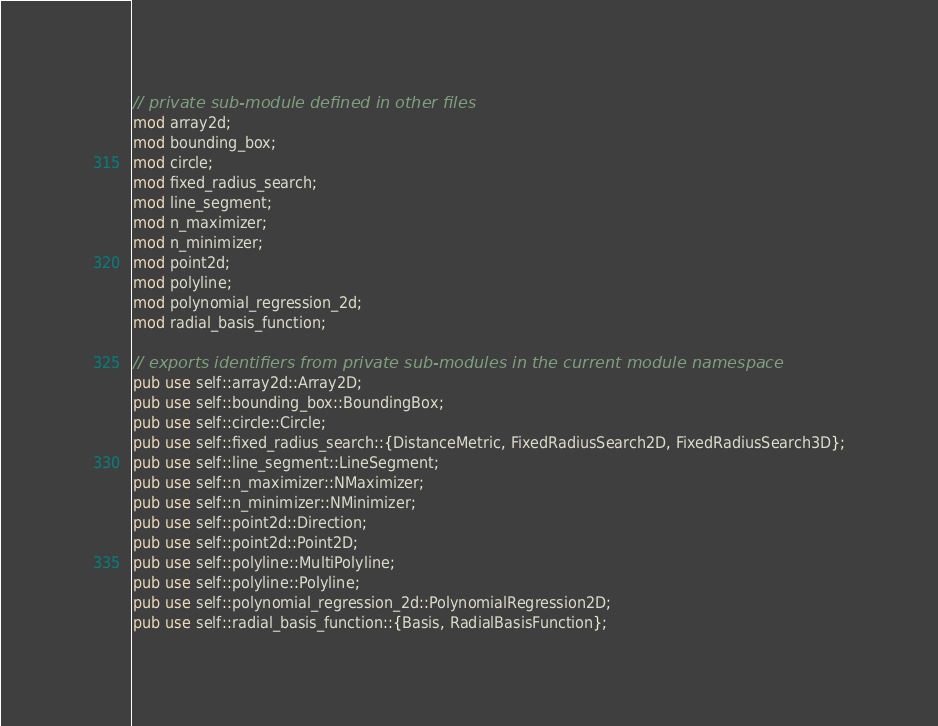<code> <loc_0><loc_0><loc_500><loc_500><_Rust_>// private sub-module defined in other files
mod array2d;
mod bounding_box;
mod circle;
mod fixed_radius_search;
mod line_segment;
mod n_maximizer;
mod n_minimizer;
mod point2d;
mod polyline;
mod polynomial_regression_2d;
mod radial_basis_function;

// exports identifiers from private sub-modules in the current module namespace
pub use self::array2d::Array2D;
pub use self::bounding_box::BoundingBox;
pub use self::circle::Circle;
pub use self::fixed_radius_search::{DistanceMetric, FixedRadiusSearch2D, FixedRadiusSearch3D};
pub use self::line_segment::LineSegment;
pub use self::n_maximizer::NMaximizer;
pub use self::n_minimizer::NMinimizer;
pub use self::point2d::Direction;
pub use self::point2d::Point2D;
pub use self::polyline::MultiPolyline;
pub use self::polyline::Polyline;
pub use self::polynomial_regression_2d::PolynomialRegression2D;
pub use self::radial_basis_function::{Basis, RadialBasisFunction};
</code> 